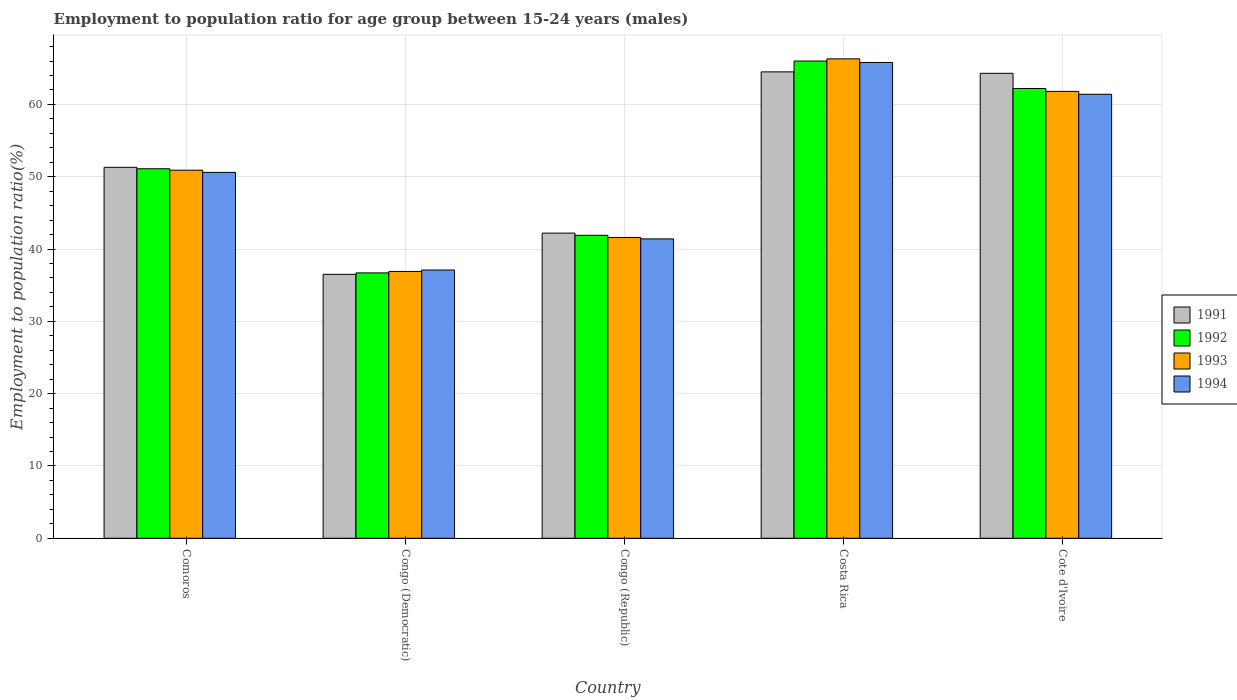How many different coloured bars are there?
Give a very brief answer. 4. How many bars are there on the 2nd tick from the right?
Provide a succinct answer. 4. What is the label of the 3rd group of bars from the left?
Make the answer very short. Congo (Republic). In how many cases, is the number of bars for a given country not equal to the number of legend labels?
Your answer should be compact. 0. What is the employment to population ratio in 1991 in Congo (Republic)?
Keep it short and to the point. 42.2. Across all countries, what is the maximum employment to population ratio in 1991?
Offer a very short reply. 64.5. Across all countries, what is the minimum employment to population ratio in 1991?
Your answer should be compact. 36.5. In which country was the employment to population ratio in 1991 minimum?
Offer a very short reply. Congo (Democratic). What is the total employment to population ratio in 1994 in the graph?
Your answer should be very brief. 256.3. What is the difference between the employment to population ratio in 1991 in Congo (Republic) and that in Cote d'Ivoire?
Keep it short and to the point. -22.1. What is the difference between the employment to population ratio in 1991 in Congo (Democratic) and the employment to population ratio in 1992 in Comoros?
Ensure brevity in your answer.  -14.6. What is the average employment to population ratio in 1994 per country?
Your response must be concise. 51.26. What is the difference between the employment to population ratio of/in 1991 and employment to population ratio of/in 1992 in Congo (Democratic)?
Your answer should be compact. -0.2. In how many countries, is the employment to population ratio in 1992 greater than 16 %?
Ensure brevity in your answer.  5. What is the ratio of the employment to population ratio in 1991 in Comoros to that in Cote d'Ivoire?
Your response must be concise. 0.8. Is the employment to population ratio in 1992 in Congo (Democratic) less than that in Congo (Republic)?
Give a very brief answer. Yes. What is the difference between the highest and the second highest employment to population ratio in 1991?
Give a very brief answer. 13.2. What is the difference between the highest and the lowest employment to population ratio in 1994?
Give a very brief answer. 28.7. Is the sum of the employment to population ratio in 1992 in Congo (Democratic) and Costa Rica greater than the maximum employment to population ratio in 1991 across all countries?
Offer a very short reply. Yes. What does the 2nd bar from the left in Costa Rica represents?
Give a very brief answer. 1992. Is it the case that in every country, the sum of the employment to population ratio in 1991 and employment to population ratio in 1993 is greater than the employment to population ratio in 1994?
Your response must be concise. Yes. Are all the bars in the graph horizontal?
Make the answer very short. No. Does the graph contain any zero values?
Your answer should be compact. No. What is the title of the graph?
Make the answer very short. Employment to population ratio for age group between 15-24 years (males). What is the Employment to population ratio(%) of 1991 in Comoros?
Your response must be concise. 51.3. What is the Employment to population ratio(%) of 1992 in Comoros?
Your response must be concise. 51.1. What is the Employment to population ratio(%) in 1993 in Comoros?
Make the answer very short. 50.9. What is the Employment to population ratio(%) of 1994 in Comoros?
Provide a succinct answer. 50.6. What is the Employment to population ratio(%) in 1991 in Congo (Democratic)?
Give a very brief answer. 36.5. What is the Employment to population ratio(%) in 1992 in Congo (Democratic)?
Your response must be concise. 36.7. What is the Employment to population ratio(%) of 1993 in Congo (Democratic)?
Make the answer very short. 36.9. What is the Employment to population ratio(%) in 1994 in Congo (Democratic)?
Offer a terse response. 37.1. What is the Employment to population ratio(%) of 1991 in Congo (Republic)?
Make the answer very short. 42.2. What is the Employment to population ratio(%) of 1992 in Congo (Republic)?
Give a very brief answer. 41.9. What is the Employment to population ratio(%) in 1993 in Congo (Republic)?
Offer a terse response. 41.6. What is the Employment to population ratio(%) in 1994 in Congo (Republic)?
Your answer should be compact. 41.4. What is the Employment to population ratio(%) in 1991 in Costa Rica?
Provide a succinct answer. 64.5. What is the Employment to population ratio(%) of 1993 in Costa Rica?
Your answer should be very brief. 66.3. What is the Employment to population ratio(%) of 1994 in Costa Rica?
Your response must be concise. 65.8. What is the Employment to population ratio(%) in 1991 in Cote d'Ivoire?
Provide a short and direct response. 64.3. What is the Employment to population ratio(%) of 1992 in Cote d'Ivoire?
Ensure brevity in your answer.  62.2. What is the Employment to population ratio(%) in 1993 in Cote d'Ivoire?
Provide a succinct answer. 61.8. What is the Employment to population ratio(%) in 1994 in Cote d'Ivoire?
Make the answer very short. 61.4. Across all countries, what is the maximum Employment to population ratio(%) in 1991?
Offer a terse response. 64.5. Across all countries, what is the maximum Employment to population ratio(%) in 1993?
Keep it short and to the point. 66.3. Across all countries, what is the maximum Employment to population ratio(%) in 1994?
Make the answer very short. 65.8. Across all countries, what is the minimum Employment to population ratio(%) of 1991?
Your answer should be compact. 36.5. Across all countries, what is the minimum Employment to population ratio(%) of 1992?
Offer a very short reply. 36.7. Across all countries, what is the minimum Employment to population ratio(%) of 1993?
Your answer should be compact. 36.9. Across all countries, what is the minimum Employment to population ratio(%) in 1994?
Ensure brevity in your answer.  37.1. What is the total Employment to population ratio(%) in 1991 in the graph?
Make the answer very short. 258.8. What is the total Employment to population ratio(%) in 1992 in the graph?
Keep it short and to the point. 257.9. What is the total Employment to population ratio(%) of 1993 in the graph?
Your answer should be very brief. 257.5. What is the total Employment to population ratio(%) of 1994 in the graph?
Provide a succinct answer. 256.3. What is the difference between the Employment to population ratio(%) of 1993 in Comoros and that in Congo (Democratic)?
Make the answer very short. 14. What is the difference between the Employment to population ratio(%) of 1991 in Comoros and that in Congo (Republic)?
Make the answer very short. 9.1. What is the difference between the Employment to population ratio(%) in 1992 in Comoros and that in Congo (Republic)?
Your answer should be very brief. 9.2. What is the difference between the Employment to population ratio(%) in 1993 in Comoros and that in Congo (Republic)?
Ensure brevity in your answer.  9.3. What is the difference between the Employment to population ratio(%) in 1991 in Comoros and that in Costa Rica?
Your answer should be very brief. -13.2. What is the difference between the Employment to population ratio(%) of 1992 in Comoros and that in Costa Rica?
Offer a very short reply. -14.9. What is the difference between the Employment to population ratio(%) in 1993 in Comoros and that in Costa Rica?
Offer a very short reply. -15.4. What is the difference between the Employment to population ratio(%) of 1994 in Comoros and that in Costa Rica?
Keep it short and to the point. -15.2. What is the difference between the Employment to population ratio(%) in 1992 in Congo (Democratic) and that in Congo (Republic)?
Give a very brief answer. -5.2. What is the difference between the Employment to population ratio(%) in 1993 in Congo (Democratic) and that in Congo (Republic)?
Offer a very short reply. -4.7. What is the difference between the Employment to population ratio(%) of 1991 in Congo (Democratic) and that in Costa Rica?
Your answer should be very brief. -28. What is the difference between the Employment to population ratio(%) in 1992 in Congo (Democratic) and that in Costa Rica?
Offer a terse response. -29.3. What is the difference between the Employment to population ratio(%) of 1993 in Congo (Democratic) and that in Costa Rica?
Make the answer very short. -29.4. What is the difference between the Employment to population ratio(%) in 1994 in Congo (Democratic) and that in Costa Rica?
Your answer should be compact. -28.7. What is the difference between the Employment to population ratio(%) of 1991 in Congo (Democratic) and that in Cote d'Ivoire?
Make the answer very short. -27.8. What is the difference between the Employment to population ratio(%) in 1992 in Congo (Democratic) and that in Cote d'Ivoire?
Your answer should be compact. -25.5. What is the difference between the Employment to population ratio(%) in 1993 in Congo (Democratic) and that in Cote d'Ivoire?
Make the answer very short. -24.9. What is the difference between the Employment to population ratio(%) in 1994 in Congo (Democratic) and that in Cote d'Ivoire?
Offer a terse response. -24.3. What is the difference between the Employment to population ratio(%) in 1991 in Congo (Republic) and that in Costa Rica?
Make the answer very short. -22.3. What is the difference between the Employment to population ratio(%) in 1992 in Congo (Republic) and that in Costa Rica?
Your answer should be very brief. -24.1. What is the difference between the Employment to population ratio(%) of 1993 in Congo (Republic) and that in Costa Rica?
Your response must be concise. -24.7. What is the difference between the Employment to population ratio(%) in 1994 in Congo (Republic) and that in Costa Rica?
Your answer should be compact. -24.4. What is the difference between the Employment to population ratio(%) of 1991 in Congo (Republic) and that in Cote d'Ivoire?
Your response must be concise. -22.1. What is the difference between the Employment to population ratio(%) of 1992 in Congo (Republic) and that in Cote d'Ivoire?
Offer a terse response. -20.3. What is the difference between the Employment to population ratio(%) of 1993 in Congo (Republic) and that in Cote d'Ivoire?
Ensure brevity in your answer.  -20.2. What is the difference between the Employment to population ratio(%) of 1991 in Comoros and the Employment to population ratio(%) of 1992 in Congo (Democratic)?
Provide a short and direct response. 14.6. What is the difference between the Employment to population ratio(%) of 1991 in Comoros and the Employment to population ratio(%) of 1993 in Congo (Democratic)?
Offer a terse response. 14.4. What is the difference between the Employment to population ratio(%) of 1991 in Comoros and the Employment to population ratio(%) of 1994 in Congo (Democratic)?
Make the answer very short. 14.2. What is the difference between the Employment to population ratio(%) in 1993 in Comoros and the Employment to population ratio(%) in 1994 in Congo (Democratic)?
Provide a succinct answer. 13.8. What is the difference between the Employment to population ratio(%) in 1992 in Comoros and the Employment to population ratio(%) in 1993 in Congo (Republic)?
Make the answer very short. 9.5. What is the difference between the Employment to population ratio(%) of 1991 in Comoros and the Employment to population ratio(%) of 1992 in Costa Rica?
Ensure brevity in your answer.  -14.7. What is the difference between the Employment to population ratio(%) of 1991 in Comoros and the Employment to population ratio(%) of 1993 in Costa Rica?
Your answer should be very brief. -15. What is the difference between the Employment to population ratio(%) in 1992 in Comoros and the Employment to population ratio(%) in 1993 in Costa Rica?
Your response must be concise. -15.2. What is the difference between the Employment to population ratio(%) in 1992 in Comoros and the Employment to population ratio(%) in 1994 in Costa Rica?
Make the answer very short. -14.7. What is the difference between the Employment to population ratio(%) of 1993 in Comoros and the Employment to population ratio(%) of 1994 in Costa Rica?
Provide a short and direct response. -14.9. What is the difference between the Employment to population ratio(%) in 1993 in Comoros and the Employment to population ratio(%) in 1994 in Cote d'Ivoire?
Give a very brief answer. -10.5. What is the difference between the Employment to population ratio(%) in 1991 in Congo (Democratic) and the Employment to population ratio(%) in 1994 in Congo (Republic)?
Provide a short and direct response. -4.9. What is the difference between the Employment to population ratio(%) in 1992 in Congo (Democratic) and the Employment to population ratio(%) in 1994 in Congo (Republic)?
Keep it short and to the point. -4.7. What is the difference between the Employment to population ratio(%) of 1991 in Congo (Democratic) and the Employment to population ratio(%) of 1992 in Costa Rica?
Provide a succinct answer. -29.5. What is the difference between the Employment to population ratio(%) in 1991 in Congo (Democratic) and the Employment to population ratio(%) in 1993 in Costa Rica?
Provide a succinct answer. -29.8. What is the difference between the Employment to population ratio(%) in 1991 in Congo (Democratic) and the Employment to population ratio(%) in 1994 in Costa Rica?
Your response must be concise. -29.3. What is the difference between the Employment to population ratio(%) in 1992 in Congo (Democratic) and the Employment to population ratio(%) in 1993 in Costa Rica?
Your answer should be very brief. -29.6. What is the difference between the Employment to population ratio(%) in 1992 in Congo (Democratic) and the Employment to population ratio(%) in 1994 in Costa Rica?
Provide a short and direct response. -29.1. What is the difference between the Employment to population ratio(%) of 1993 in Congo (Democratic) and the Employment to population ratio(%) of 1994 in Costa Rica?
Offer a terse response. -28.9. What is the difference between the Employment to population ratio(%) in 1991 in Congo (Democratic) and the Employment to population ratio(%) in 1992 in Cote d'Ivoire?
Your response must be concise. -25.7. What is the difference between the Employment to population ratio(%) of 1991 in Congo (Democratic) and the Employment to population ratio(%) of 1993 in Cote d'Ivoire?
Keep it short and to the point. -25.3. What is the difference between the Employment to population ratio(%) of 1991 in Congo (Democratic) and the Employment to population ratio(%) of 1994 in Cote d'Ivoire?
Your answer should be very brief. -24.9. What is the difference between the Employment to population ratio(%) of 1992 in Congo (Democratic) and the Employment to population ratio(%) of 1993 in Cote d'Ivoire?
Offer a terse response. -25.1. What is the difference between the Employment to population ratio(%) of 1992 in Congo (Democratic) and the Employment to population ratio(%) of 1994 in Cote d'Ivoire?
Your answer should be compact. -24.7. What is the difference between the Employment to population ratio(%) of 1993 in Congo (Democratic) and the Employment to population ratio(%) of 1994 in Cote d'Ivoire?
Your answer should be compact. -24.5. What is the difference between the Employment to population ratio(%) in 1991 in Congo (Republic) and the Employment to population ratio(%) in 1992 in Costa Rica?
Your answer should be very brief. -23.8. What is the difference between the Employment to population ratio(%) of 1991 in Congo (Republic) and the Employment to population ratio(%) of 1993 in Costa Rica?
Your answer should be compact. -24.1. What is the difference between the Employment to population ratio(%) in 1991 in Congo (Republic) and the Employment to population ratio(%) in 1994 in Costa Rica?
Provide a short and direct response. -23.6. What is the difference between the Employment to population ratio(%) in 1992 in Congo (Republic) and the Employment to population ratio(%) in 1993 in Costa Rica?
Provide a short and direct response. -24.4. What is the difference between the Employment to population ratio(%) in 1992 in Congo (Republic) and the Employment to population ratio(%) in 1994 in Costa Rica?
Your answer should be compact. -23.9. What is the difference between the Employment to population ratio(%) in 1993 in Congo (Republic) and the Employment to population ratio(%) in 1994 in Costa Rica?
Your answer should be very brief. -24.2. What is the difference between the Employment to population ratio(%) in 1991 in Congo (Republic) and the Employment to population ratio(%) in 1993 in Cote d'Ivoire?
Keep it short and to the point. -19.6. What is the difference between the Employment to population ratio(%) in 1991 in Congo (Republic) and the Employment to population ratio(%) in 1994 in Cote d'Ivoire?
Ensure brevity in your answer.  -19.2. What is the difference between the Employment to population ratio(%) of 1992 in Congo (Republic) and the Employment to population ratio(%) of 1993 in Cote d'Ivoire?
Your answer should be very brief. -19.9. What is the difference between the Employment to population ratio(%) of 1992 in Congo (Republic) and the Employment to population ratio(%) of 1994 in Cote d'Ivoire?
Make the answer very short. -19.5. What is the difference between the Employment to population ratio(%) of 1993 in Congo (Republic) and the Employment to population ratio(%) of 1994 in Cote d'Ivoire?
Provide a short and direct response. -19.8. What is the difference between the Employment to population ratio(%) in 1991 in Costa Rica and the Employment to population ratio(%) in 1993 in Cote d'Ivoire?
Offer a terse response. 2.7. What is the difference between the Employment to population ratio(%) in 1991 in Costa Rica and the Employment to population ratio(%) in 1994 in Cote d'Ivoire?
Your answer should be very brief. 3.1. What is the difference between the Employment to population ratio(%) of 1992 in Costa Rica and the Employment to population ratio(%) of 1993 in Cote d'Ivoire?
Provide a short and direct response. 4.2. What is the difference between the Employment to population ratio(%) of 1992 in Costa Rica and the Employment to population ratio(%) of 1994 in Cote d'Ivoire?
Ensure brevity in your answer.  4.6. What is the average Employment to population ratio(%) of 1991 per country?
Ensure brevity in your answer.  51.76. What is the average Employment to population ratio(%) in 1992 per country?
Offer a terse response. 51.58. What is the average Employment to population ratio(%) in 1993 per country?
Keep it short and to the point. 51.5. What is the average Employment to population ratio(%) in 1994 per country?
Provide a succinct answer. 51.26. What is the difference between the Employment to population ratio(%) in 1991 and Employment to population ratio(%) in 1992 in Comoros?
Give a very brief answer. 0.2. What is the difference between the Employment to population ratio(%) of 1992 and Employment to population ratio(%) of 1994 in Comoros?
Offer a terse response. 0.5. What is the difference between the Employment to population ratio(%) in 1991 and Employment to population ratio(%) in 1993 in Congo (Democratic)?
Offer a very short reply. -0.4. What is the difference between the Employment to population ratio(%) in 1991 and Employment to population ratio(%) in 1992 in Congo (Republic)?
Your answer should be very brief. 0.3. What is the difference between the Employment to population ratio(%) in 1991 and Employment to population ratio(%) in 1993 in Congo (Republic)?
Give a very brief answer. 0.6. What is the difference between the Employment to population ratio(%) of 1991 and Employment to population ratio(%) of 1994 in Costa Rica?
Offer a terse response. -1.3. What is the difference between the Employment to population ratio(%) of 1992 and Employment to population ratio(%) of 1993 in Costa Rica?
Make the answer very short. -0.3. What is the difference between the Employment to population ratio(%) in 1992 and Employment to population ratio(%) in 1994 in Costa Rica?
Your answer should be very brief. 0.2. What is the difference between the Employment to population ratio(%) in 1993 and Employment to population ratio(%) in 1994 in Costa Rica?
Ensure brevity in your answer.  0.5. What is the difference between the Employment to population ratio(%) in 1991 and Employment to population ratio(%) in 1992 in Cote d'Ivoire?
Make the answer very short. 2.1. What is the difference between the Employment to population ratio(%) of 1991 and Employment to population ratio(%) of 1993 in Cote d'Ivoire?
Ensure brevity in your answer.  2.5. What is the difference between the Employment to population ratio(%) in 1992 and Employment to population ratio(%) in 1993 in Cote d'Ivoire?
Offer a very short reply. 0.4. What is the difference between the Employment to population ratio(%) of 1992 and Employment to population ratio(%) of 1994 in Cote d'Ivoire?
Provide a short and direct response. 0.8. What is the ratio of the Employment to population ratio(%) in 1991 in Comoros to that in Congo (Democratic)?
Give a very brief answer. 1.41. What is the ratio of the Employment to population ratio(%) in 1992 in Comoros to that in Congo (Democratic)?
Your answer should be very brief. 1.39. What is the ratio of the Employment to population ratio(%) in 1993 in Comoros to that in Congo (Democratic)?
Provide a succinct answer. 1.38. What is the ratio of the Employment to population ratio(%) in 1994 in Comoros to that in Congo (Democratic)?
Give a very brief answer. 1.36. What is the ratio of the Employment to population ratio(%) of 1991 in Comoros to that in Congo (Republic)?
Provide a succinct answer. 1.22. What is the ratio of the Employment to population ratio(%) of 1992 in Comoros to that in Congo (Republic)?
Offer a very short reply. 1.22. What is the ratio of the Employment to population ratio(%) of 1993 in Comoros to that in Congo (Republic)?
Your response must be concise. 1.22. What is the ratio of the Employment to population ratio(%) of 1994 in Comoros to that in Congo (Republic)?
Offer a very short reply. 1.22. What is the ratio of the Employment to population ratio(%) of 1991 in Comoros to that in Costa Rica?
Your answer should be very brief. 0.8. What is the ratio of the Employment to population ratio(%) of 1992 in Comoros to that in Costa Rica?
Your answer should be compact. 0.77. What is the ratio of the Employment to population ratio(%) of 1993 in Comoros to that in Costa Rica?
Ensure brevity in your answer.  0.77. What is the ratio of the Employment to population ratio(%) of 1994 in Comoros to that in Costa Rica?
Offer a terse response. 0.77. What is the ratio of the Employment to population ratio(%) of 1991 in Comoros to that in Cote d'Ivoire?
Give a very brief answer. 0.8. What is the ratio of the Employment to population ratio(%) in 1992 in Comoros to that in Cote d'Ivoire?
Keep it short and to the point. 0.82. What is the ratio of the Employment to population ratio(%) in 1993 in Comoros to that in Cote d'Ivoire?
Ensure brevity in your answer.  0.82. What is the ratio of the Employment to population ratio(%) of 1994 in Comoros to that in Cote d'Ivoire?
Offer a terse response. 0.82. What is the ratio of the Employment to population ratio(%) in 1991 in Congo (Democratic) to that in Congo (Republic)?
Offer a terse response. 0.86. What is the ratio of the Employment to population ratio(%) in 1992 in Congo (Democratic) to that in Congo (Republic)?
Ensure brevity in your answer.  0.88. What is the ratio of the Employment to population ratio(%) in 1993 in Congo (Democratic) to that in Congo (Republic)?
Provide a succinct answer. 0.89. What is the ratio of the Employment to population ratio(%) in 1994 in Congo (Democratic) to that in Congo (Republic)?
Keep it short and to the point. 0.9. What is the ratio of the Employment to population ratio(%) of 1991 in Congo (Democratic) to that in Costa Rica?
Your answer should be compact. 0.57. What is the ratio of the Employment to population ratio(%) of 1992 in Congo (Democratic) to that in Costa Rica?
Give a very brief answer. 0.56. What is the ratio of the Employment to population ratio(%) in 1993 in Congo (Democratic) to that in Costa Rica?
Give a very brief answer. 0.56. What is the ratio of the Employment to population ratio(%) in 1994 in Congo (Democratic) to that in Costa Rica?
Provide a short and direct response. 0.56. What is the ratio of the Employment to population ratio(%) of 1991 in Congo (Democratic) to that in Cote d'Ivoire?
Keep it short and to the point. 0.57. What is the ratio of the Employment to population ratio(%) of 1992 in Congo (Democratic) to that in Cote d'Ivoire?
Provide a short and direct response. 0.59. What is the ratio of the Employment to population ratio(%) of 1993 in Congo (Democratic) to that in Cote d'Ivoire?
Your answer should be very brief. 0.6. What is the ratio of the Employment to population ratio(%) in 1994 in Congo (Democratic) to that in Cote d'Ivoire?
Give a very brief answer. 0.6. What is the ratio of the Employment to population ratio(%) in 1991 in Congo (Republic) to that in Costa Rica?
Provide a short and direct response. 0.65. What is the ratio of the Employment to population ratio(%) in 1992 in Congo (Republic) to that in Costa Rica?
Keep it short and to the point. 0.63. What is the ratio of the Employment to population ratio(%) of 1993 in Congo (Republic) to that in Costa Rica?
Your response must be concise. 0.63. What is the ratio of the Employment to population ratio(%) of 1994 in Congo (Republic) to that in Costa Rica?
Make the answer very short. 0.63. What is the ratio of the Employment to population ratio(%) of 1991 in Congo (Republic) to that in Cote d'Ivoire?
Ensure brevity in your answer.  0.66. What is the ratio of the Employment to population ratio(%) of 1992 in Congo (Republic) to that in Cote d'Ivoire?
Keep it short and to the point. 0.67. What is the ratio of the Employment to population ratio(%) of 1993 in Congo (Republic) to that in Cote d'Ivoire?
Provide a succinct answer. 0.67. What is the ratio of the Employment to population ratio(%) of 1994 in Congo (Republic) to that in Cote d'Ivoire?
Keep it short and to the point. 0.67. What is the ratio of the Employment to population ratio(%) of 1991 in Costa Rica to that in Cote d'Ivoire?
Make the answer very short. 1. What is the ratio of the Employment to population ratio(%) in 1992 in Costa Rica to that in Cote d'Ivoire?
Keep it short and to the point. 1.06. What is the ratio of the Employment to population ratio(%) in 1993 in Costa Rica to that in Cote d'Ivoire?
Your response must be concise. 1.07. What is the ratio of the Employment to population ratio(%) of 1994 in Costa Rica to that in Cote d'Ivoire?
Keep it short and to the point. 1.07. What is the difference between the highest and the second highest Employment to population ratio(%) in 1993?
Your response must be concise. 4.5. What is the difference between the highest and the lowest Employment to population ratio(%) in 1991?
Ensure brevity in your answer.  28. What is the difference between the highest and the lowest Employment to population ratio(%) in 1992?
Your answer should be compact. 29.3. What is the difference between the highest and the lowest Employment to population ratio(%) in 1993?
Give a very brief answer. 29.4. What is the difference between the highest and the lowest Employment to population ratio(%) of 1994?
Make the answer very short. 28.7. 